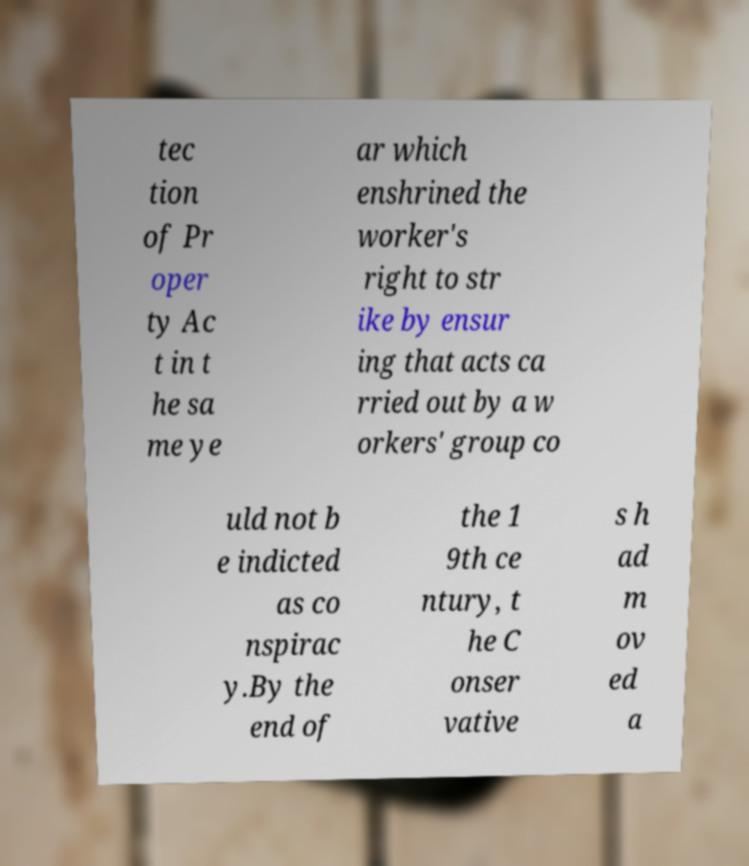Please identify and transcribe the text found in this image. tec tion of Pr oper ty Ac t in t he sa me ye ar which enshrined the worker's right to str ike by ensur ing that acts ca rried out by a w orkers' group co uld not b e indicted as co nspirac y.By the end of the 1 9th ce ntury, t he C onser vative s h ad m ov ed a 